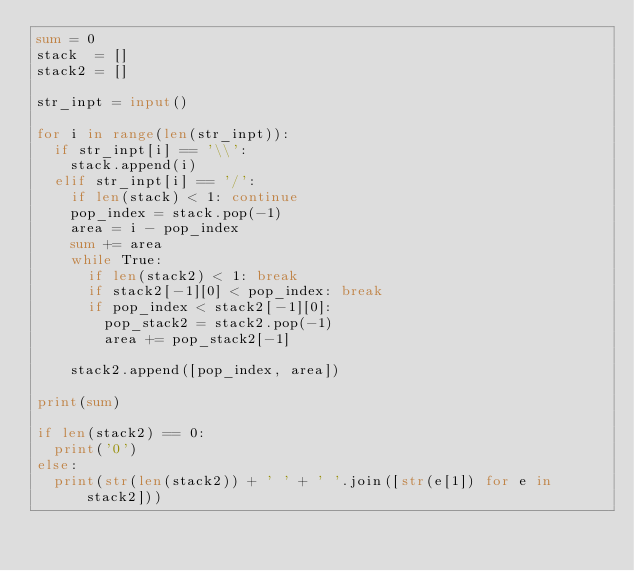Convert code to text. <code><loc_0><loc_0><loc_500><loc_500><_Python_>sum = 0
stack  = []
stack2 = []

str_inpt = input()

for i in range(len(str_inpt)):
  if str_inpt[i] == '\\':
    stack.append(i)
  elif str_inpt[i] == '/':
    if len(stack) < 1: continue
    pop_index = stack.pop(-1)
    area = i - pop_index
    sum += area
    while True:
      if len(stack2) < 1: break
      if stack2[-1][0] < pop_index: break
      if pop_index < stack2[-1][0]:
        pop_stack2 = stack2.pop(-1)
        area += pop_stack2[-1]

    stack2.append([pop_index, area])

print(sum)

if len(stack2) == 0:
  print('0')
else:
  print(str(len(stack2)) + ' ' + ' '.join([str(e[1]) for e in stack2]))
</code> 